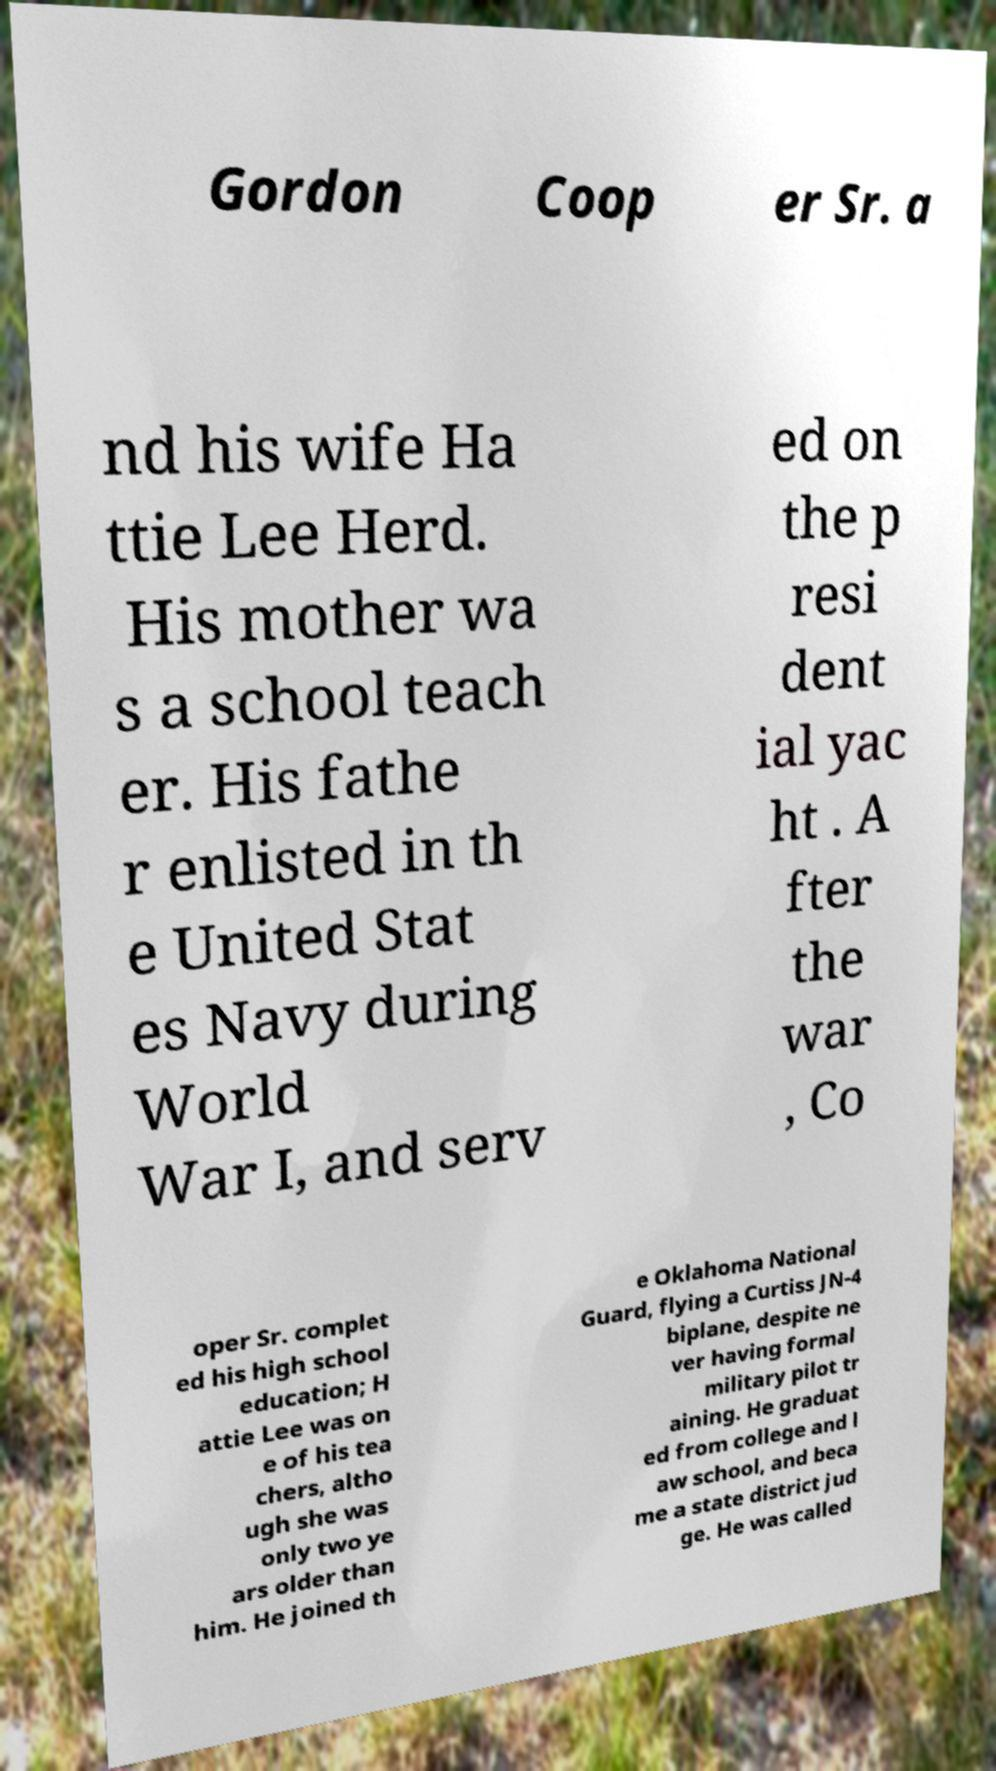What messages or text are displayed in this image? I need them in a readable, typed format. Gordon Coop er Sr. a nd his wife Ha ttie Lee Herd. His mother wa s a school teach er. His fathe r enlisted in th e United Stat es Navy during World War I, and serv ed on the p resi dent ial yac ht . A fter the war , Co oper Sr. complet ed his high school education; H attie Lee was on e of his tea chers, altho ugh she was only two ye ars older than him. He joined th e Oklahoma National Guard, flying a Curtiss JN-4 biplane, despite ne ver having formal military pilot tr aining. He graduat ed from college and l aw school, and beca me a state district jud ge. He was called 